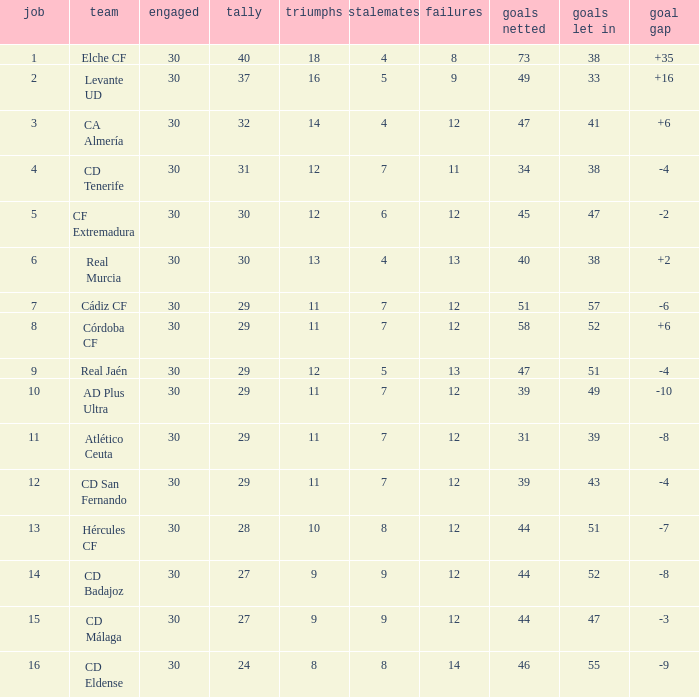What is the sum of the goals with less than 30 points, a position less than 10, and more than 57 goals against? None. 